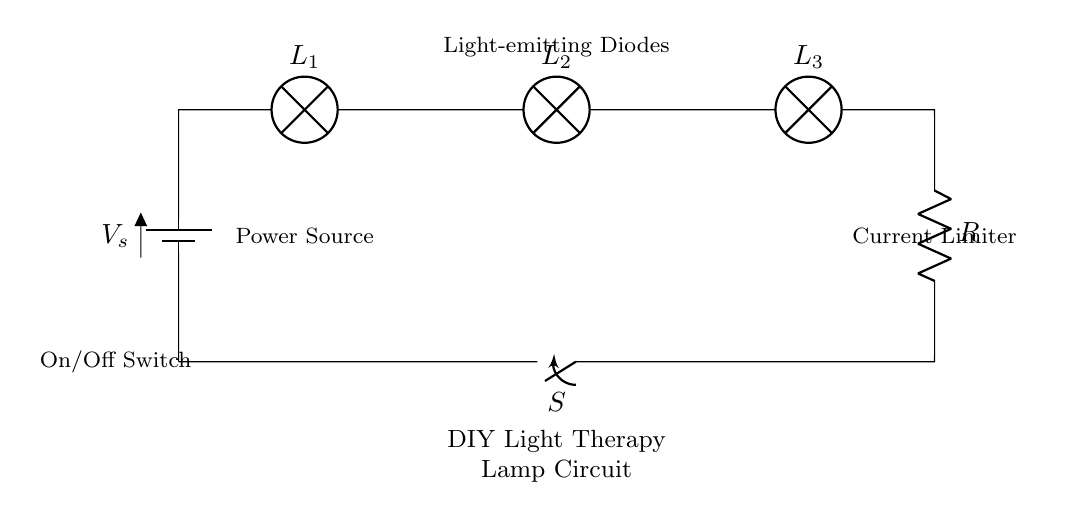What is the type of power source used in this circuit? The power source is a battery, as indicated by the label next to it in the circuit diagram.
Answer: Battery How many light-emitting diodes are in this circuit? The circuit diagram shows three lamps labeled L1, L2, and L3, which are presumably light-emitting diodes.
Answer: Three What is the function of the resistor in the circuit? The resistor serves as a current limiter, which helps to prevent excessive current from flowing through the light-emitting diodes and potentially damaging them.
Answer: Current limiter What happens when the switch is closed? Closing the switch completes the circuit, allowing current to flow from the power source through the lamps and the resistor, thus turning on the light therapy lamp.
Answer: Turns on What is the role of the switch in the circuit? The switch acts as an on/off control for the circuit, allowing the user to easily turn the light therapy lamp on or off as needed.
Answer: Control What is the layout of the components in the circuit? The components are arranged in a series configuration, where the battery, lamps, resistor, and switch are connected end-to-end, so the same current flows through each component.
Answer: Series configuration 